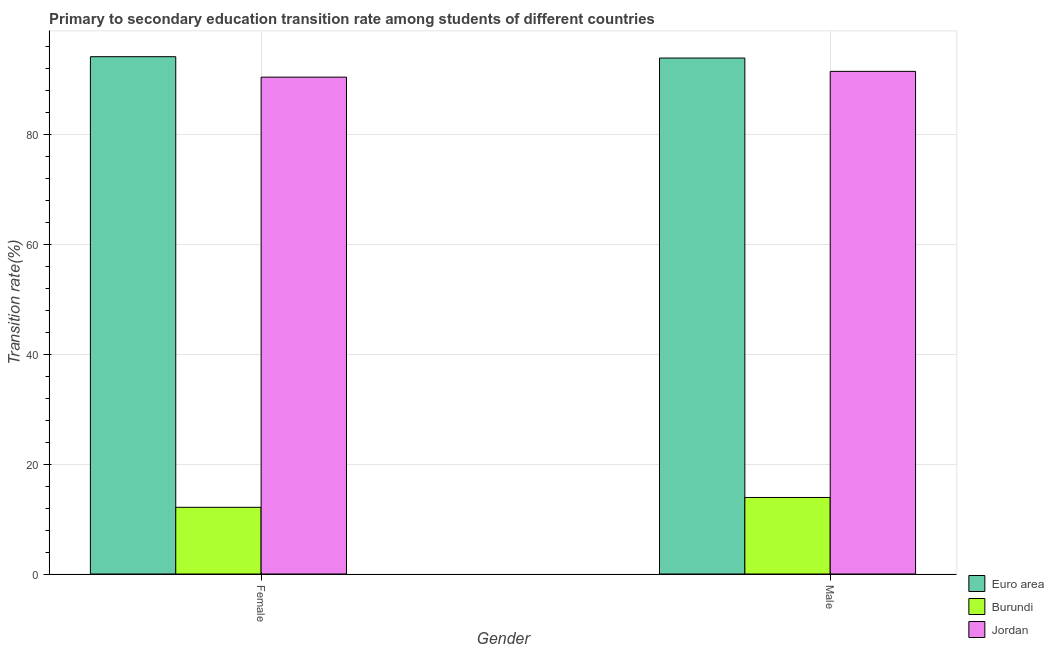How many different coloured bars are there?
Offer a terse response. 3. Are the number of bars per tick equal to the number of legend labels?
Give a very brief answer. Yes. How many bars are there on the 1st tick from the left?
Give a very brief answer. 3. What is the label of the 1st group of bars from the left?
Your answer should be compact. Female. What is the transition rate among female students in Jordan?
Give a very brief answer. 90.41. Across all countries, what is the maximum transition rate among male students?
Keep it short and to the point. 93.88. Across all countries, what is the minimum transition rate among male students?
Make the answer very short. 13.93. In which country was the transition rate among male students maximum?
Your answer should be compact. Euro area. In which country was the transition rate among male students minimum?
Your answer should be compact. Burundi. What is the total transition rate among female students in the graph?
Keep it short and to the point. 196.68. What is the difference between the transition rate among female students in Burundi and that in Jordan?
Your answer should be compact. -78.27. What is the difference between the transition rate among female students in Jordan and the transition rate among male students in Euro area?
Offer a terse response. -3.47. What is the average transition rate among female students per country?
Ensure brevity in your answer.  65.56. What is the difference between the transition rate among female students and transition rate among male students in Burundi?
Provide a succinct answer. -1.79. What is the ratio of the transition rate among female students in Euro area to that in Jordan?
Ensure brevity in your answer.  1.04. Is the transition rate among male students in Burundi less than that in Euro area?
Give a very brief answer. Yes. What does the 3rd bar from the left in Male represents?
Make the answer very short. Jordan. How many bars are there?
Your answer should be compact. 6. Are all the bars in the graph horizontal?
Ensure brevity in your answer.  No. How many countries are there in the graph?
Make the answer very short. 3. Are the values on the major ticks of Y-axis written in scientific E-notation?
Ensure brevity in your answer.  No. Does the graph contain any zero values?
Make the answer very short. No. Does the graph contain grids?
Provide a succinct answer. Yes. How are the legend labels stacked?
Provide a short and direct response. Vertical. What is the title of the graph?
Your response must be concise. Primary to secondary education transition rate among students of different countries. Does "Paraguay" appear as one of the legend labels in the graph?
Keep it short and to the point. No. What is the label or title of the X-axis?
Offer a terse response. Gender. What is the label or title of the Y-axis?
Your answer should be very brief. Transition rate(%). What is the Transition rate(%) in Euro area in Female?
Provide a succinct answer. 94.13. What is the Transition rate(%) of Burundi in Female?
Provide a succinct answer. 12.14. What is the Transition rate(%) of Jordan in Female?
Your answer should be very brief. 90.41. What is the Transition rate(%) in Euro area in Male?
Give a very brief answer. 93.88. What is the Transition rate(%) in Burundi in Male?
Your answer should be compact. 13.93. What is the Transition rate(%) of Jordan in Male?
Your answer should be very brief. 91.46. Across all Gender, what is the maximum Transition rate(%) in Euro area?
Offer a very short reply. 94.13. Across all Gender, what is the maximum Transition rate(%) of Burundi?
Provide a short and direct response. 13.93. Across all Gender, what is the maximum Transition rate(%) in Jordan?
Provide a short and direct response. 91.46. Across all Gender, what is the minimum Transition rate(%) of Euro area?
Provide a succinct answer. 93.88. Across all Gender, what is the minimum Transition rate(%) of Burundi?
Your answer should be very brief. 12.14. Across all Gender, what is the minimum Transition rate(%) of Jordan?
Offer a terse response. 90.41. What is the total Transition rate(%) in Euro area in the graph?
Offer a very short reply. 188.02. What is the total Transition rate(%) of Burundi in the graph?
Provide a succinct answer. 26.06. What is the total Transition rate(%) in Jordan in the graph?
Provide a succinct answer. 181.87. What is the difference between the Transition rate(%) of Euro area in Female and that in Male?
Make the answer very short. 0.25. What is the difference between the Transition rate(%) in Burundi in Female and that in Male?
Keep it short and to the point. -1.79. What is the difference between the Transition rate(%) of Jordan in Female and that in Male?
Your response must be concise. -1.05. What is the difference between the Transition rate(%) of Euro area in Female and the Transition rate(%) of Burundi in Male?
Give a very brief answer. 80.21. What is the difference between the Transition rate(%) in Euro area in Female and the Transition rate(%) in Jordan in Male?
Offer a terse response. 2.67. What is the difference between the Transition rate(%) of Burundi in Female and the Transition rate(%) of Jordan in Male?
Ensure brevity in your answer.  -79.32. What is the average Transition rate(%) in Euro area per Gender?
Offer a very short reply. 94.01. What is the average Transition rate(%) in Burundi per Gender?
Offer a very short reply. 13.03. What is the average Transition rate(%) of Jordan per Gender?
Provide a succinct answer. 90.94. What is the difference between the Transition rate(%) in Euro area and Transition rate(%) in Burundi in Female?
Give a very brief answer. 81.99. What is the difference between the Transition rate(%) of Euro area and Transition rate(%) of Jordan in Female?
Offer a terse response. 3.72. What is the difference between the Transition rate(%) in Burundi and Transition rate(%) in Jordan in Female?
Your answer should be very brief. -78.27. What is the difference between the Transition rate(%) of Euro area and Transition rate(%) of Burundi in Male?
Ensure brevity in your answer.  79.96. What is the difference between the Transition rate(%) of Euro area and Transition rate(%) of Jordan in Male?
Keep it short and to the point. 2.42. What is the difference between the Transition rate(%) in Burundi and Transition rate(%) in Jordan in Male?
Your answer should be very brief. -77.53. What is the ratio of the Transition rate(%) in Burundi in Female to that in Male?
Your answer should be very brief. 0.87. What is the difference between the highest and the second highest Transition rate(%) in Euro area?
Keep it short and to the point. 0.25. What is the difference between the highest and the second highest Transition rate(%) of Burundi?
Your response must be concise. 1.79. What is the difference between the highest and the second highest Transition rate(%) of Jordan?
Your answer should be compact. 1.05. What is the difference between the highest and the lowest Transition rate(%) of Euro area?
Offer a very short reply. 0.25. What is the difference between the highest and the lowest Transition rate(%) in Burundi?
Your answer should be compact. 1.79. What is the difference between the highest and the lowest Transition rate(%) in Jordan?
Provide a succinct answer. 1.05. 